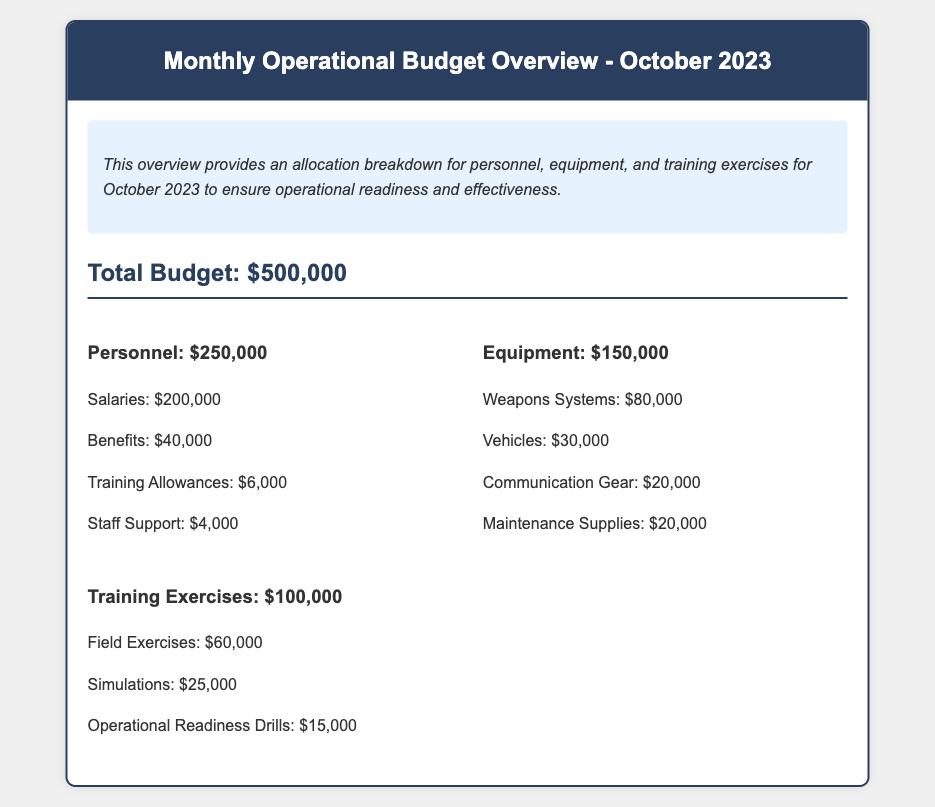what is the total budget? The total budget is explicitly stated in the document as $500,000.
Answer: $500,000 how much is allocated for personnel? The allocation for personnel is detailed in the document, showing a total of $250,000.
Answer: $250,000 what is the amount for benefits? The document specifies that benefits account for $40,000.
Answer: $40,000 what are the expenses for training exercises? The expenses for training exercises are summarized as $100,000 in total.
Answer: $100,000 how much is allocated for vehicles? The budget details state that the allocation for vehicles is $30,000.
Answer: $30,000 how much is spent on field exercises? The document shows that field exercises amount to $60,000.
Answer: $60,000 what is the total allocation for equipment? The total allocation for equipment, as indicated in the document, is $150,000.
Answer: $150,000 which item has the highest allocation in personnel? The highest allocation in personnel is for salaries, which is $200,000.
Answer: salaries how much is budgeted for operational readiness drills? The budget sets aside $15,000 for operational readiness drills.
Answer: $15,000 how much is allocated for maintenance supplies? The document specifies that maintenance supplies cost $20,000.
Answer: $20,000 